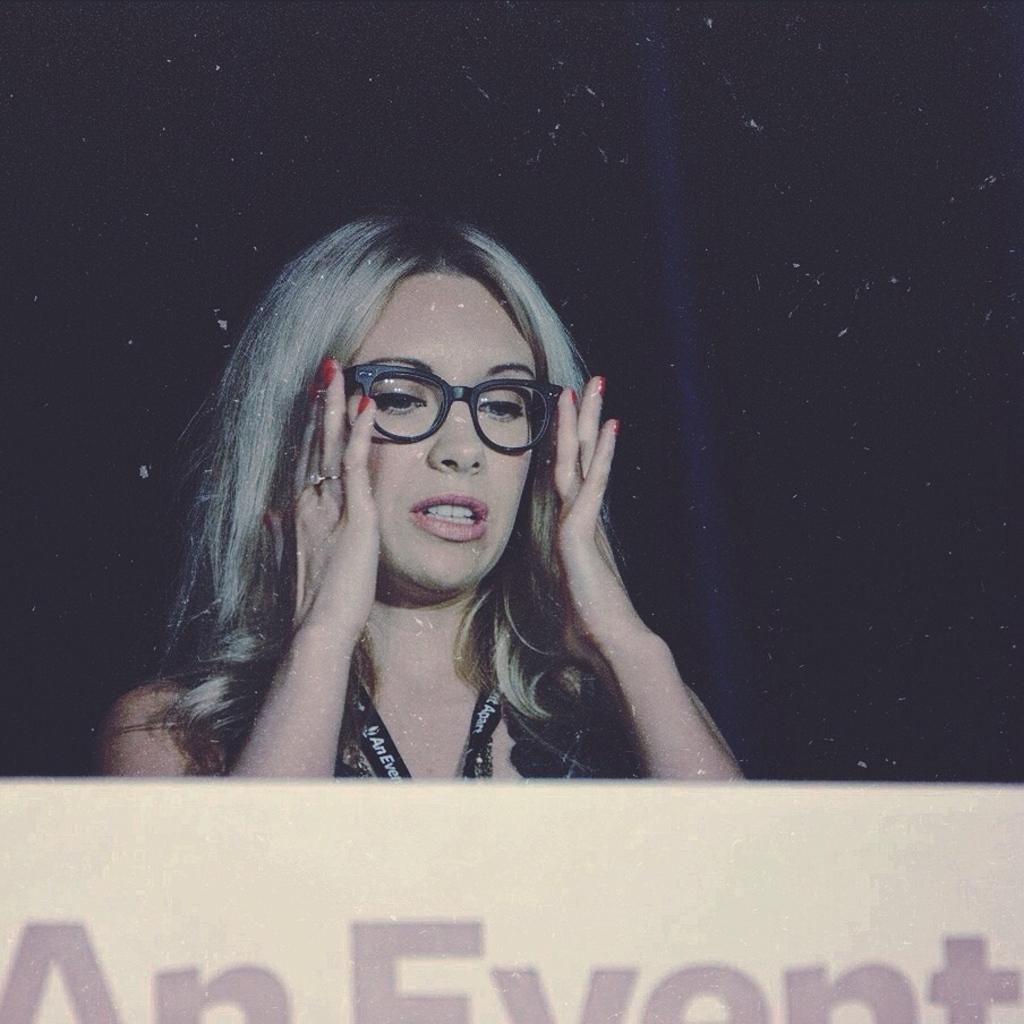Can you describe this image briefly? In this image I can see a person wearing black color dress, in front I can see a board in white color and I can see dark background. 